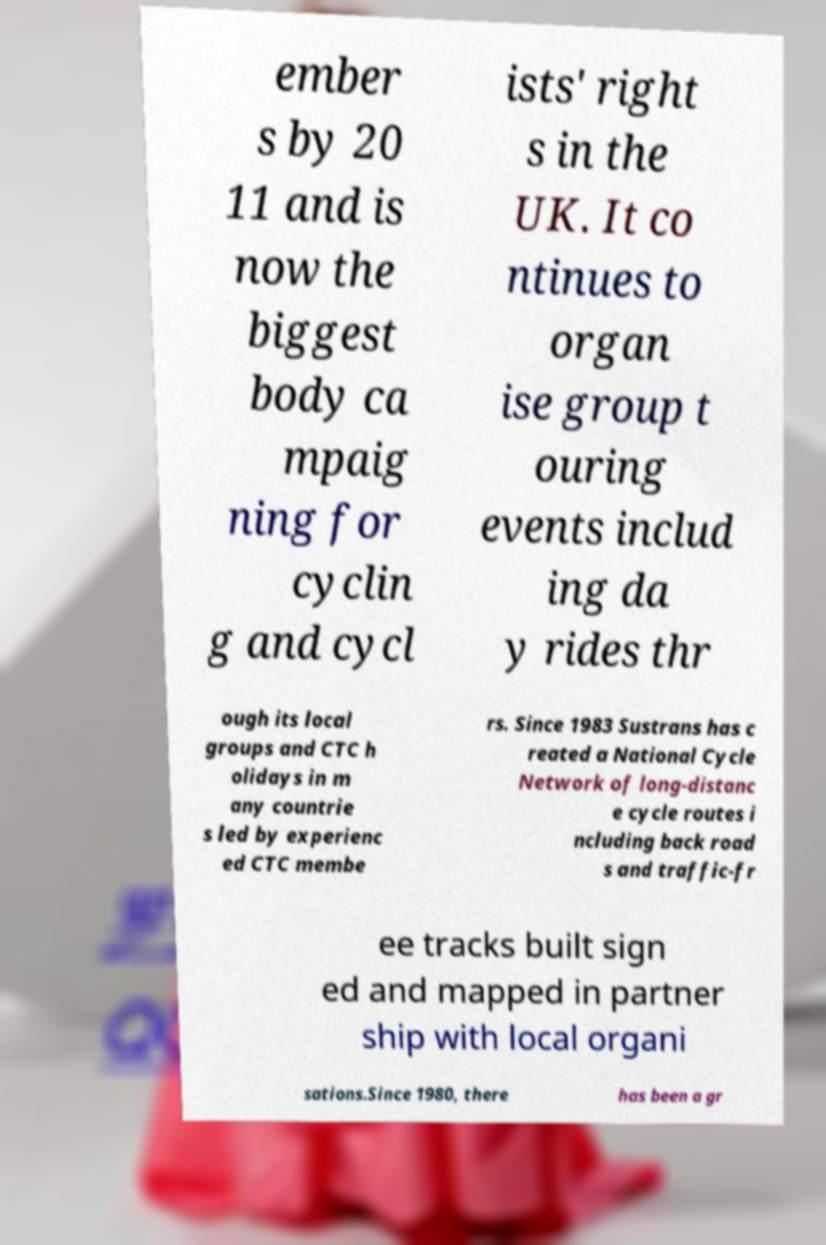There's text embedded in this image that I need extracted. Can you transcribe it verbatim? ember s by 20 11 and is now the biggest body ca mpaig ning for cyclin g and cycl ists' right s in the UK. It co ntinues to organ ise group t ouring events includ ing da y rides thr ough its local groups and CTC h olidays in m any countrie s led by experienc ed CTC membe rs. Since 1983 Sustrans has c reated a National Cycle Network of long-distanc e cycle routes i ncluding back road s and traffic-fr ee tracks built sign ed and mapped in partner ship with local organi sations.Since 1980, there has been a gr 